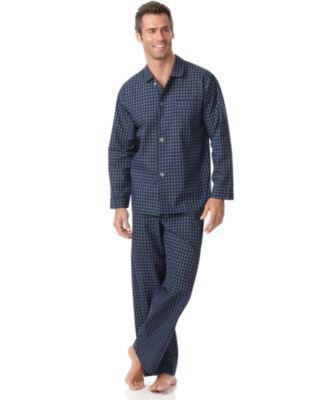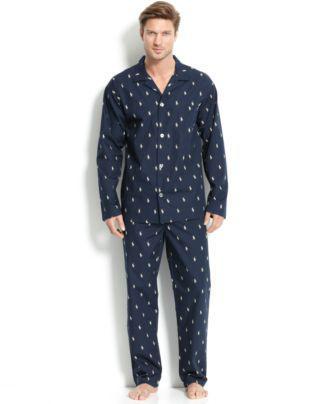The first image is the image on the left, the second image is the image on the right. Evaluate the accuracy of this statement regarding the images: "The image on the left does not have a white background". Is it true? Answer yes or no. No. 